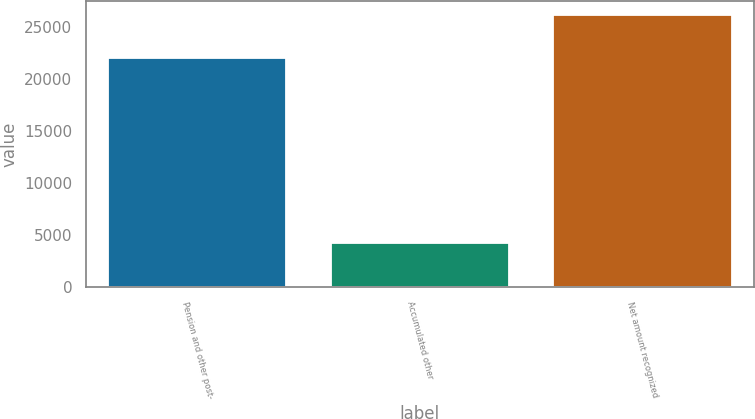<chart> <loc_0><loc_0><loc_500><loc_500><bar_chart><fcel>Pension and other post-<fcel>Accumulated other<fcel>Net amount recognized<nl><fcel>21955<fcel>4197<fcel>26152<nl></chart> 